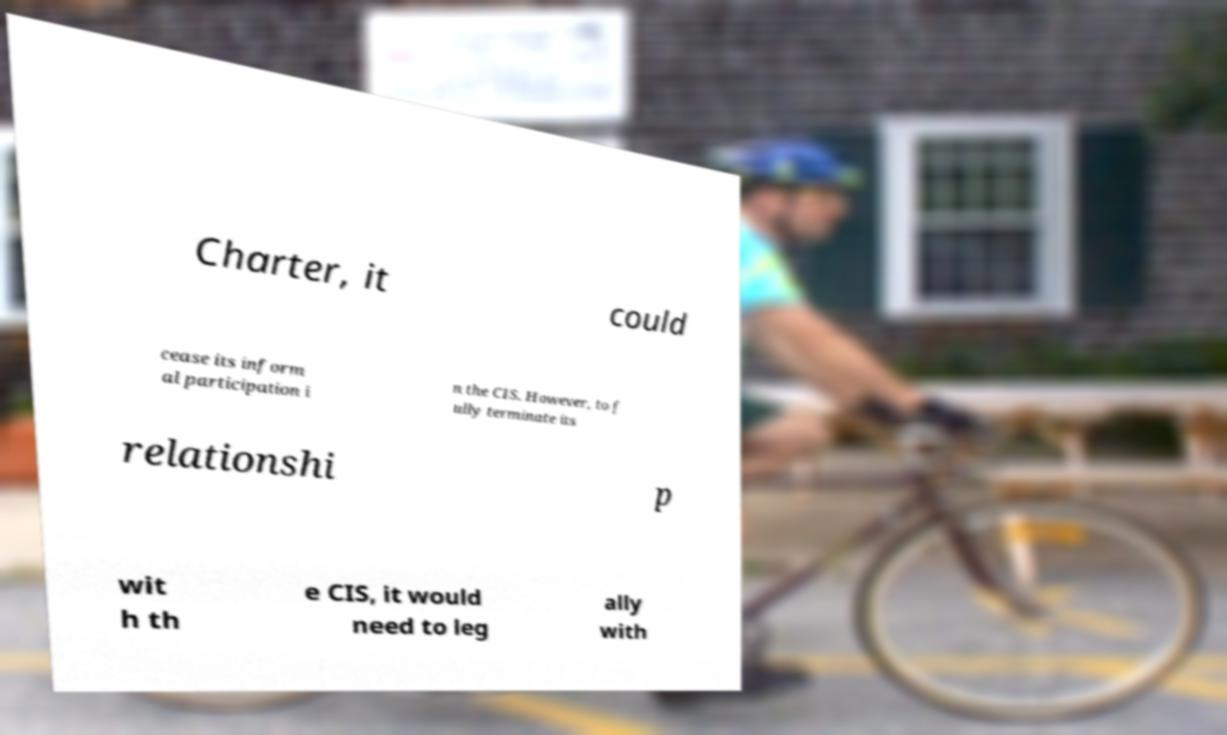Can you read and provide the text displayed in the image?This photo seems to have some interesting text. Can you extract and type it out for me? Charter, it could cease its inform al participation i n the CIS. However, to f ully terminate its relationshi p wit h th e CIS, it would need to leg ally with 